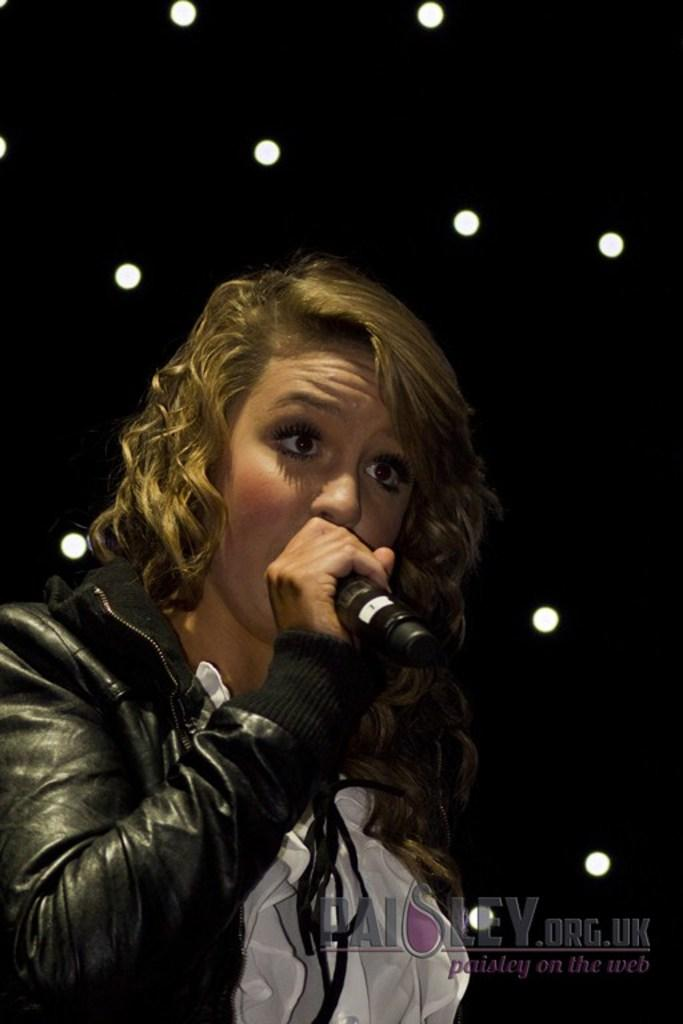What is the person in the image holding? The person is holding a microphone in the image. What can be seen in the background of the image? There are lights in the background of the image. Is there any additional information or branding on the image? Yes, there is a watermark on the image. What type of soda is being poured into the microphone in the image? There is no soda present in the image, and the microphone is not being used for pouring any liquid. 